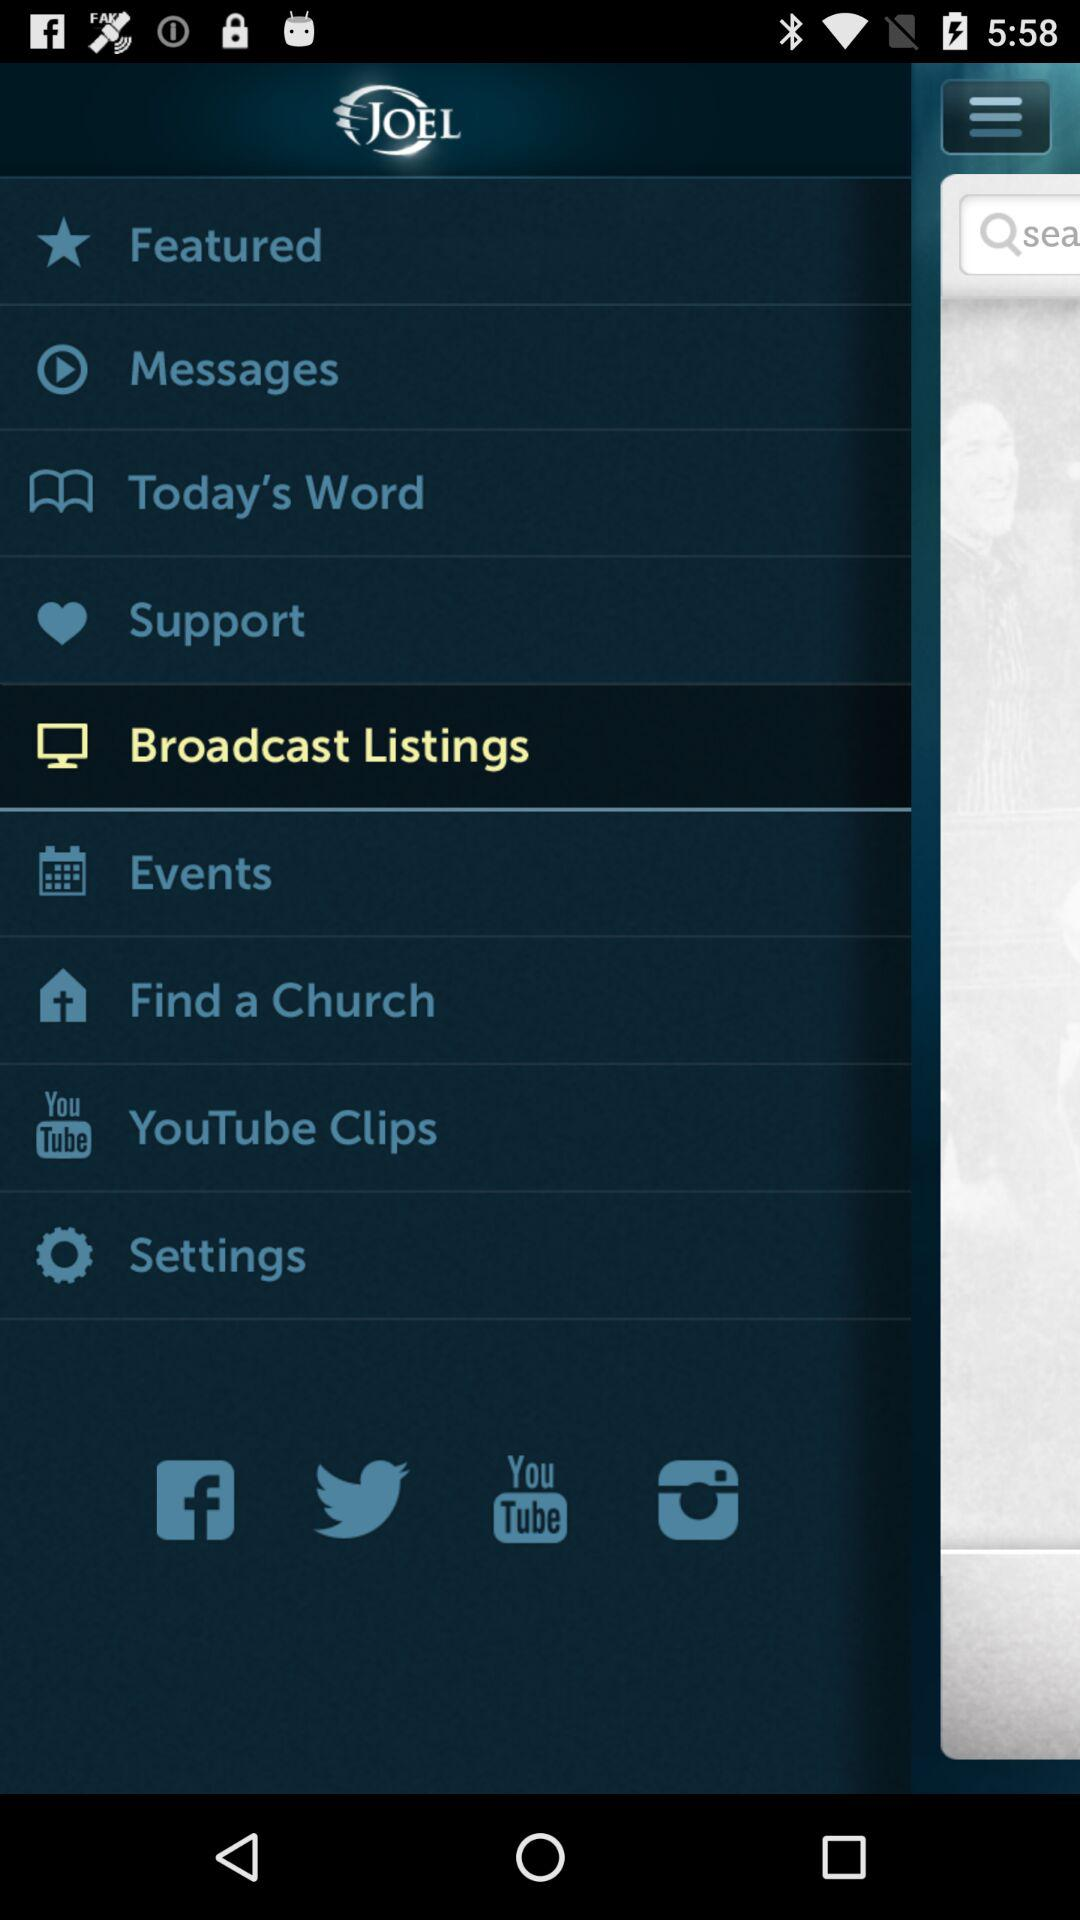What is the application name? The application name is "Joel Osteen". 